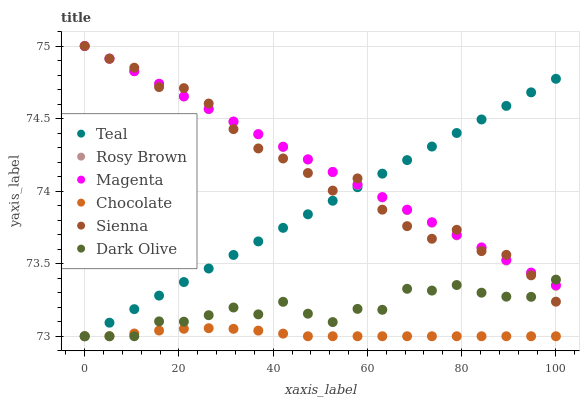Does Chocolate have the minimum area under the curve?
Answer yes or no. Yes. Does Magenta have the maximum area under the curve?
Answer yes or no. Yes. Does Rosy Brown have the minimum area under the curve?
Answer yes or no. No. Does Rosy Brown have the maximum area under the curve?
Answer yes or no. No. Is Magenta the smoothest?
Answer yes or no. Yes. Is Sienna the roughest?
Answer yes or no. Yes. Is Rosy Brown the smoothest?
Answer yes or no. No. Is Rosy Brown the roughest?
Answer yes or no. No. Does Dark Olive have the lowest value?
Answer yes or no. Yes. Does Rosy Brown have the lowest value?
Answer yes or no. No. Does Magenta have the highest value?
Answer yes or no. Yes. Does Chocolate have the highest value?
Answer yes or no. No. Is Chocolate less than Magenta?
Answer yes or no. Yes. Is Magenta greater than Chocolate?
Answer yes or no. Yes. Does Dark Olive intersect Magenta?
Answer yes or no. Yes. Is Dark Olive less than Magenta?
Answer yes or no. No. Is Dark Olive greater than Magenta?
Answer yes or no. No. Does Chocolate intersect Magenta?
Answer yes or no. No. 